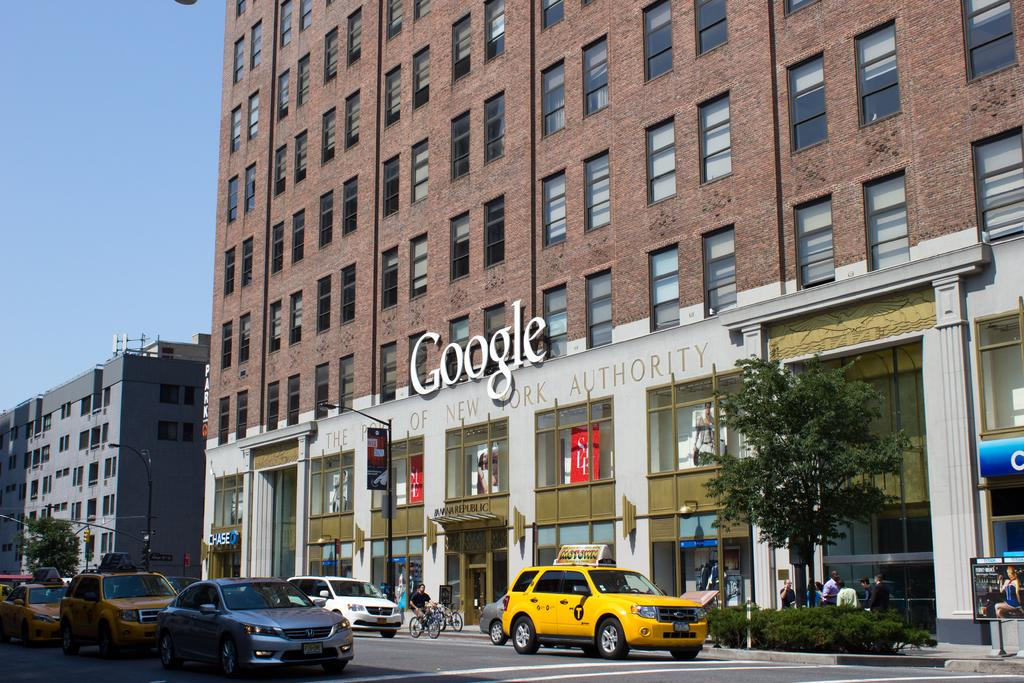<image>
Summarize the visual content of the image. a Google sign that is above a little building 